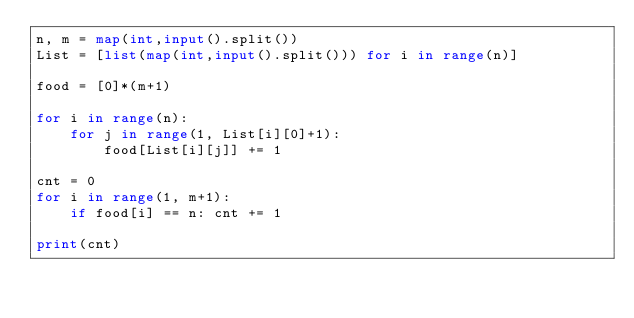<code> <loc_0><loc_0><loc_500><loc_500><_Python_>n, m = map(int,input().split())
List = [list(map(int,input().split())) for i in range(n)]

food = [0]*(m+1)

for i in range(n):
    for j in range(1, List[i][0]+1):
        food[List[i][j]] += 1

cnt = 0
for i in range(1, m+1):
    if food[i] == n: cnt += 1

print(cnt)
</code> 